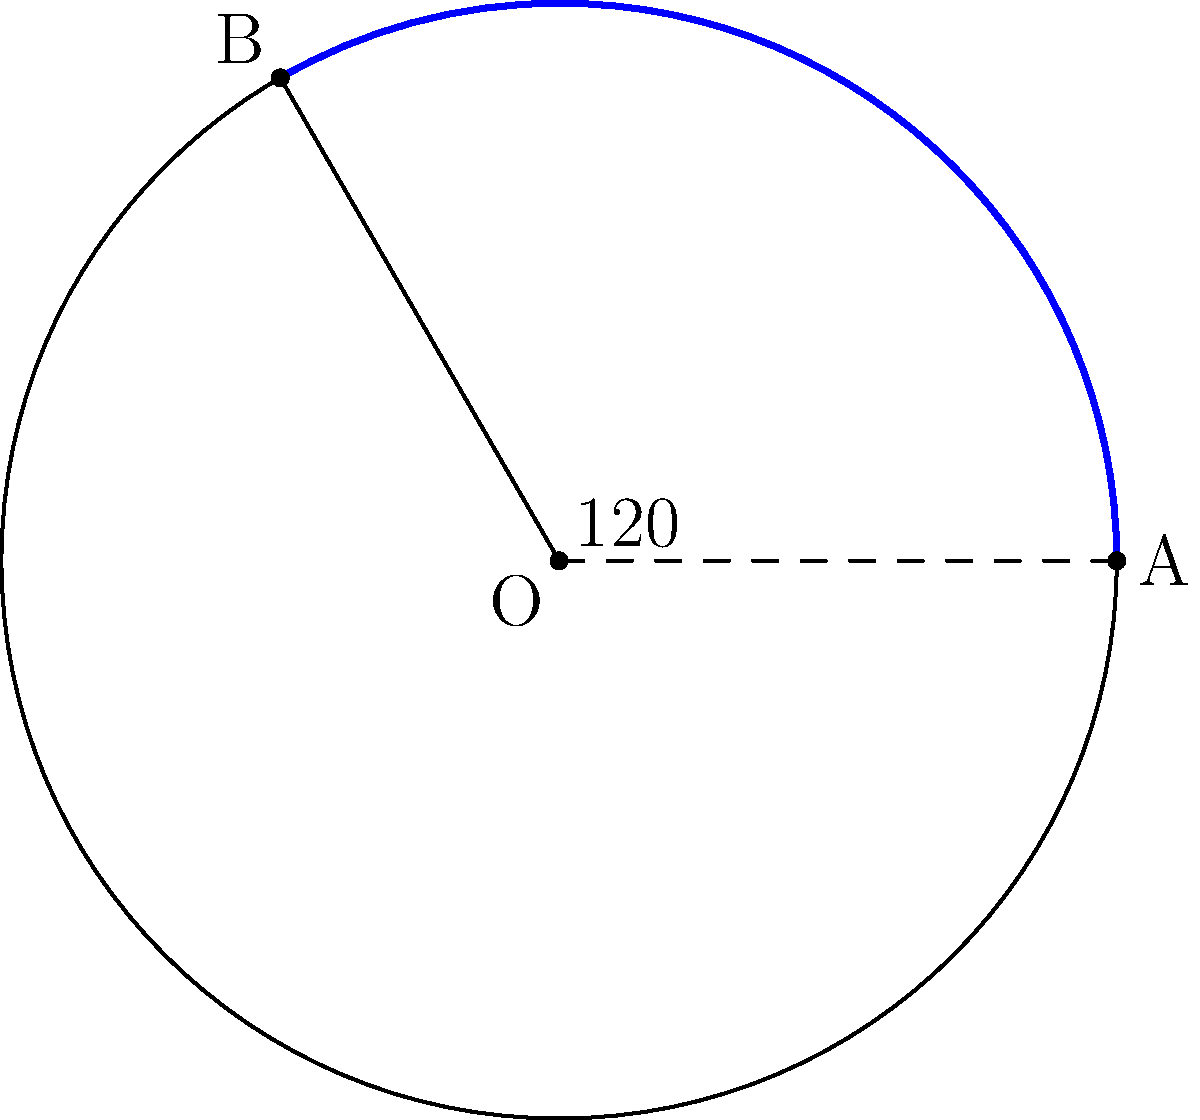As part of your sustainable tourism initiative, you're designing a circular nature reserve with a radius of 1.5 km. A scenic hiking trail needs to be constructed along an arc of the reserve's boundary, spanning an angle of 120° at the center. Calculate the length of this trail to the nearest meter. To solve this problem, we'll use the formula for arc length:

$$s = r\theta$$

Where:
$s$ = arc length
$r$ = radius of the circle
$\theta$ = angle in radians

Step 1: Convert the angle from degrees to radians
$$\theta = 120° \times \frac{\pi}{180°} = \frac{2\pi}{3} \approx 2.0944 \text{ radians}$$

Step 2: Apply the arc length formula
$$s = r\theta = 1.5 \text{ km} \times \frac{2\pi}{3}$$

Step 3: Calculate the result
$$s = 1.5 \times \frac{2\pi}{3} = \pi \text{ km} \approx 3.1416 \text{ km}$$

Step 4: Convert to meters and round to the nearest meter
$$s \approx 3141.6 \text{ m} \approx 3142 \text{ m}$$
Answer: 3142 m 